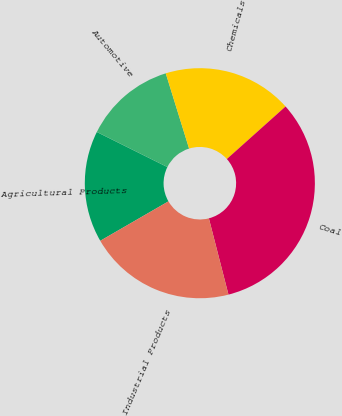<chart> <loc_0><loc_0><loc_500><loc_500><pie_chart><fcel>Agricultural Products<fcel>Automotive<fcel>Chemicals<fcel>Coal<fcel>Industrial Products<nl><fcel>15.69%<fcel>12.87%<fcel>18.17%<fcel>32.62%<fcel>20.66%<nl></chart> 